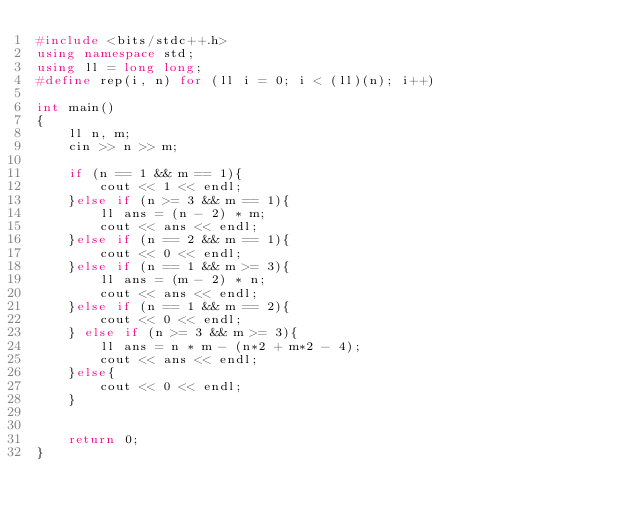<code> <loc_0><loc_0><loc_500><loc_500><_C++_>#include <bits/stdc++.h>
using namespace std;
using ll = long long;
#define rep(i, n) for (ll i = 0; i < (ll)(n); i++)

int main()
{
    ll n, m;
    cin >> n >> m;

    if (n == 1 && m == 1){
        cout << 1 << endl;
    }else if (n >= 3 && m == 1){
        ll ans = (n - 2) * m;
        cout << ans << endl;
    }else if (n == 2 && m == 1){
        cout << 0 << endl;
    }else if (n == 1 && m >= 3){
        ll ans = (m - 2) * n;
        cout << ans << endl;
    }else if (n == 1 && m == 2){
        cout << 0 << endl;
    } else if (n >= 3 && m >= 3){
        ll ans = n * m - (n*2 + m*2 - 4);
        cout << ans << endl;
    }else{
        cout << 0 << endl;
    }


    return 0;
}
</code> 